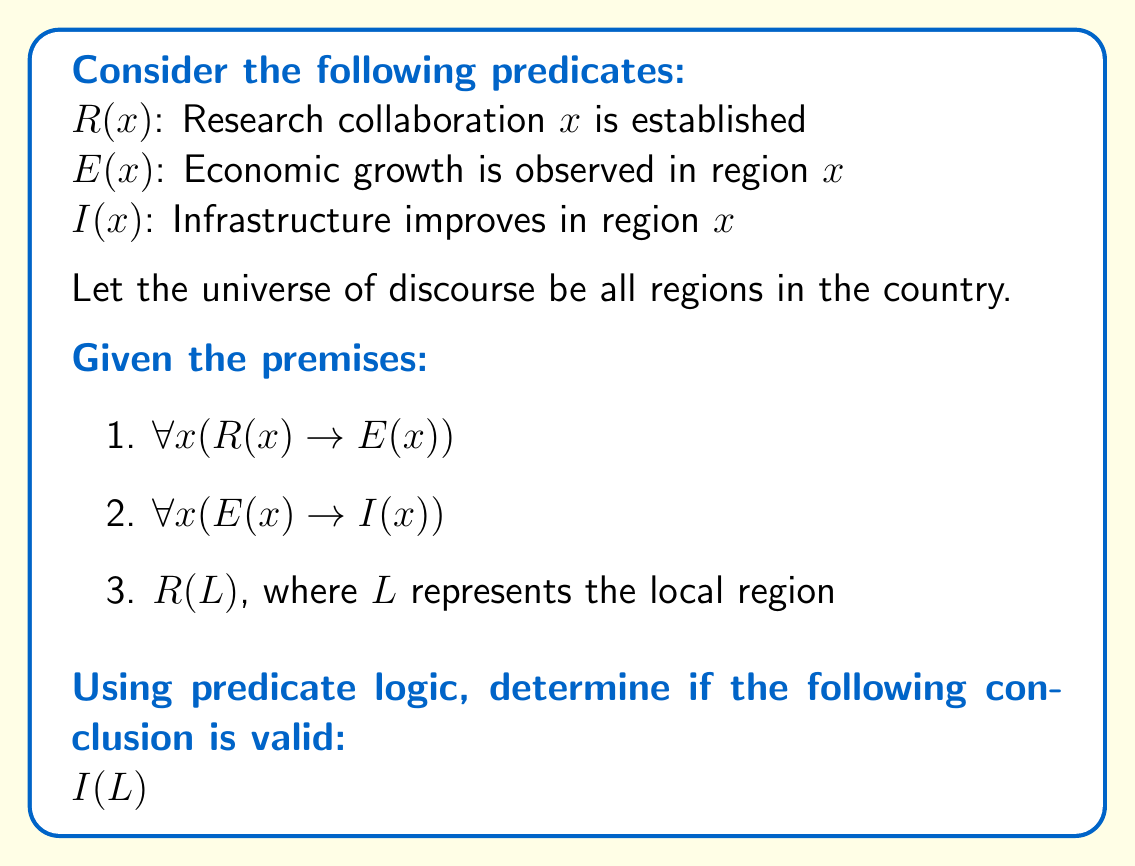Help me with this question. To determine if the conclusion $I(L)$ is valid, we'll use a step-by-step logical deduction:

1. We start with the given premises:
   a) $\forall x (R(x) \rightarrow E(x))$
   b) $\forall x (E(x) \rightarrow I(x))$
   c) $R(L)$

2. From premise (c), we know that $R(L)$ is true for the local region $L$.

3. We can apply premise (a) to the local region $L$:
   $R(L) \rightarrow E(L)$

4. Since we know $R(L)$ is true (from step 2) and $R(L) \rightarrow E(L)$ (from step 3), we can use modus ponens to conclude:
   $E(L)$

5. Now we can apply premise (b) to the local region $L$:
   $E(L) \rightarrow I(L)$

6. Since we know $E(L)$ is true (from step 4) and $E(L) \rightarrow I(L)$ (from step 5), we can use modus ponens again to conclude:
   $I(L)$

Therefore, we have logically deduced $I(L)$ from the given premises, which means the conclusion is valid.

This logical deduction demonstrates that if research collaboration is established in the local region, it will lead to economic growth, which in turn will result in improved infrastructure in that region.
Answer: The conclusion $I(L)$ is valid. The predicate logic deduction proves that if research collaboration is established in the local region, it will ultimately lead to improved infrastructure in that region. 